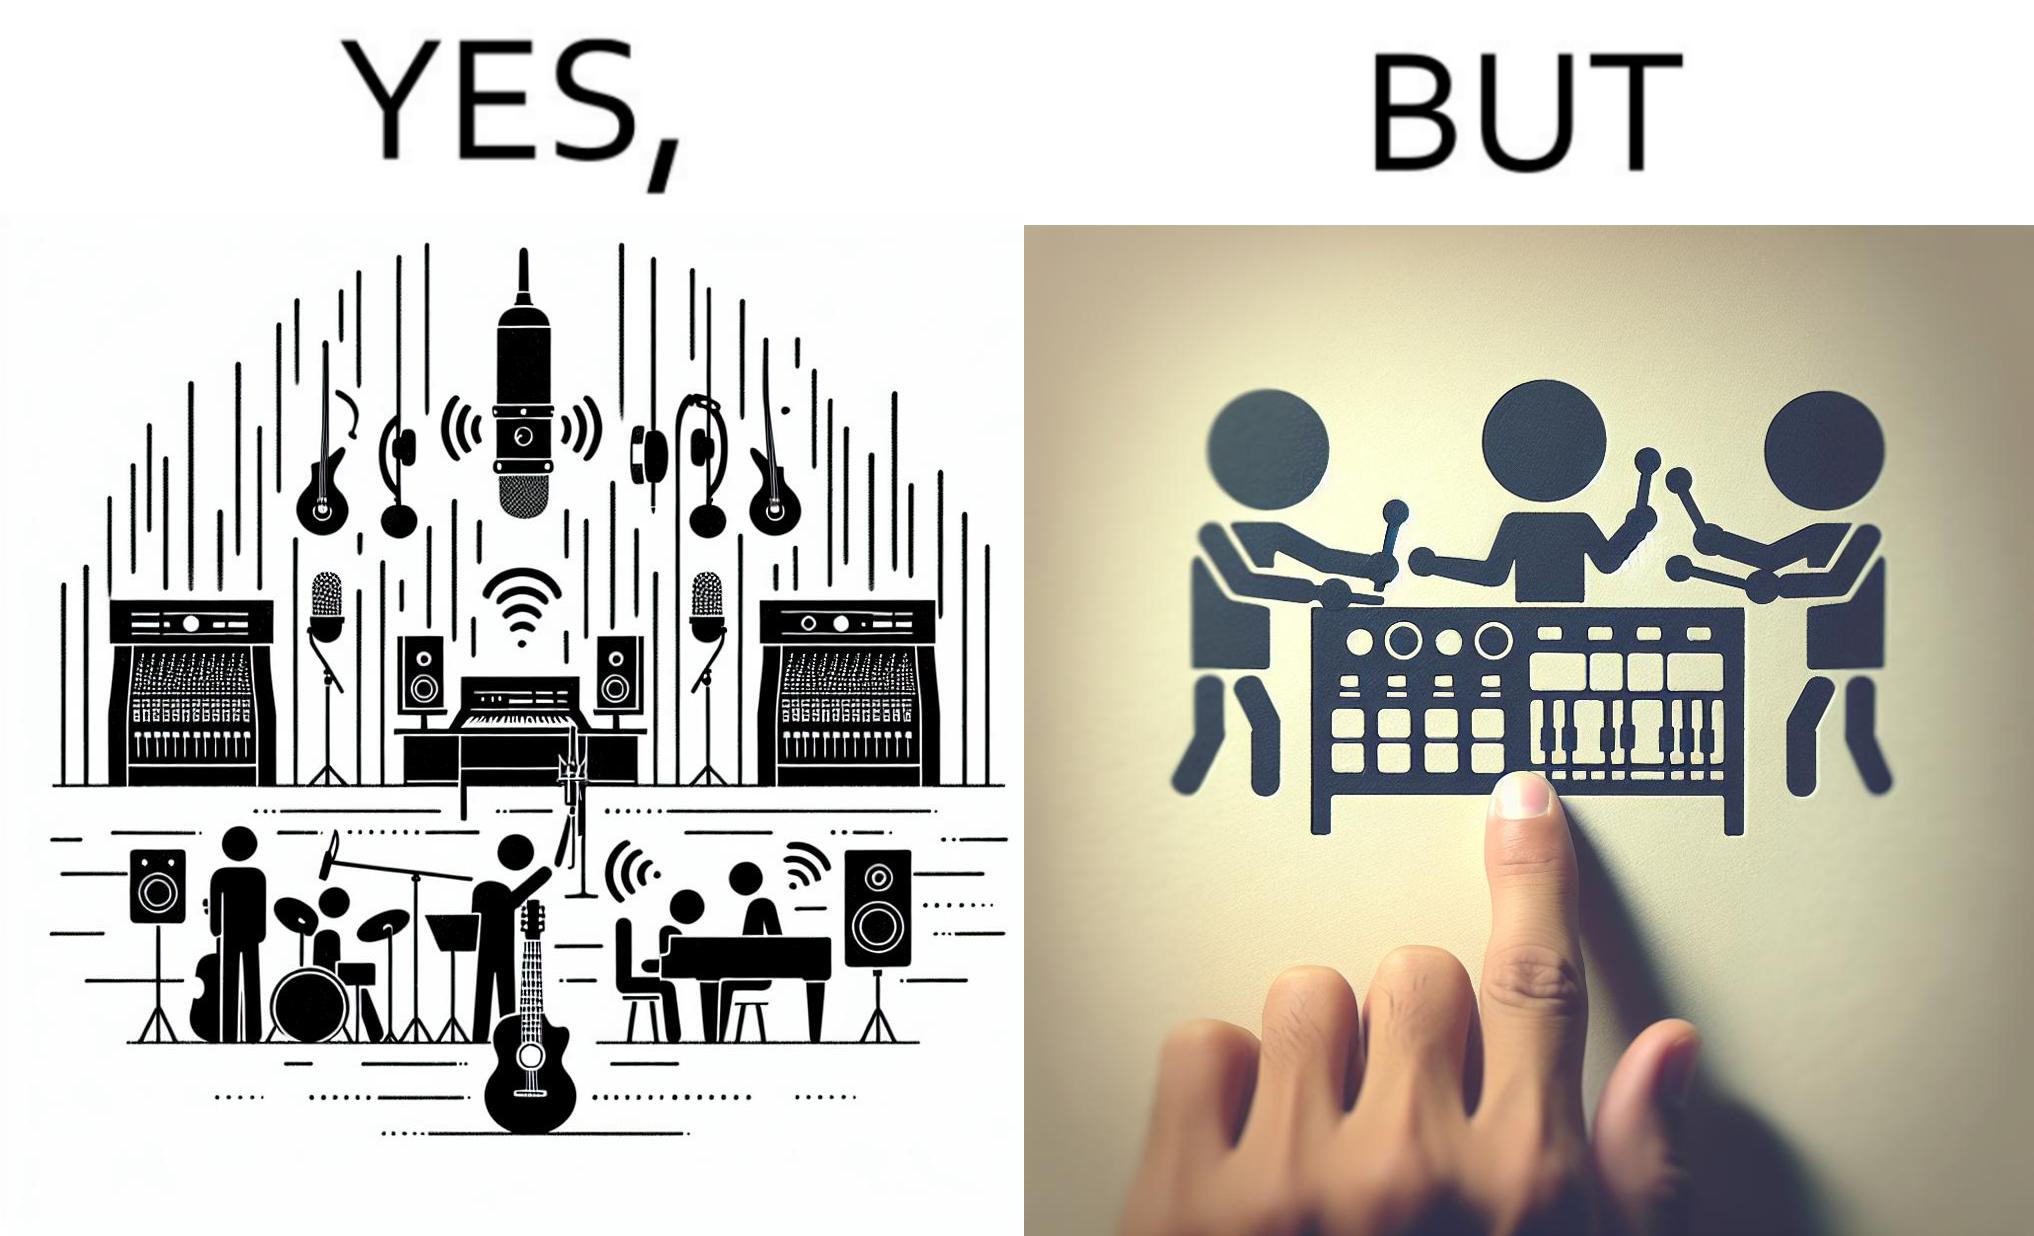Describe the satirical element in this image. The image overall is funny because even though people have great music studios and instruments to create and record music, they use electronic replacements of the musical instruments to achieve the task. 